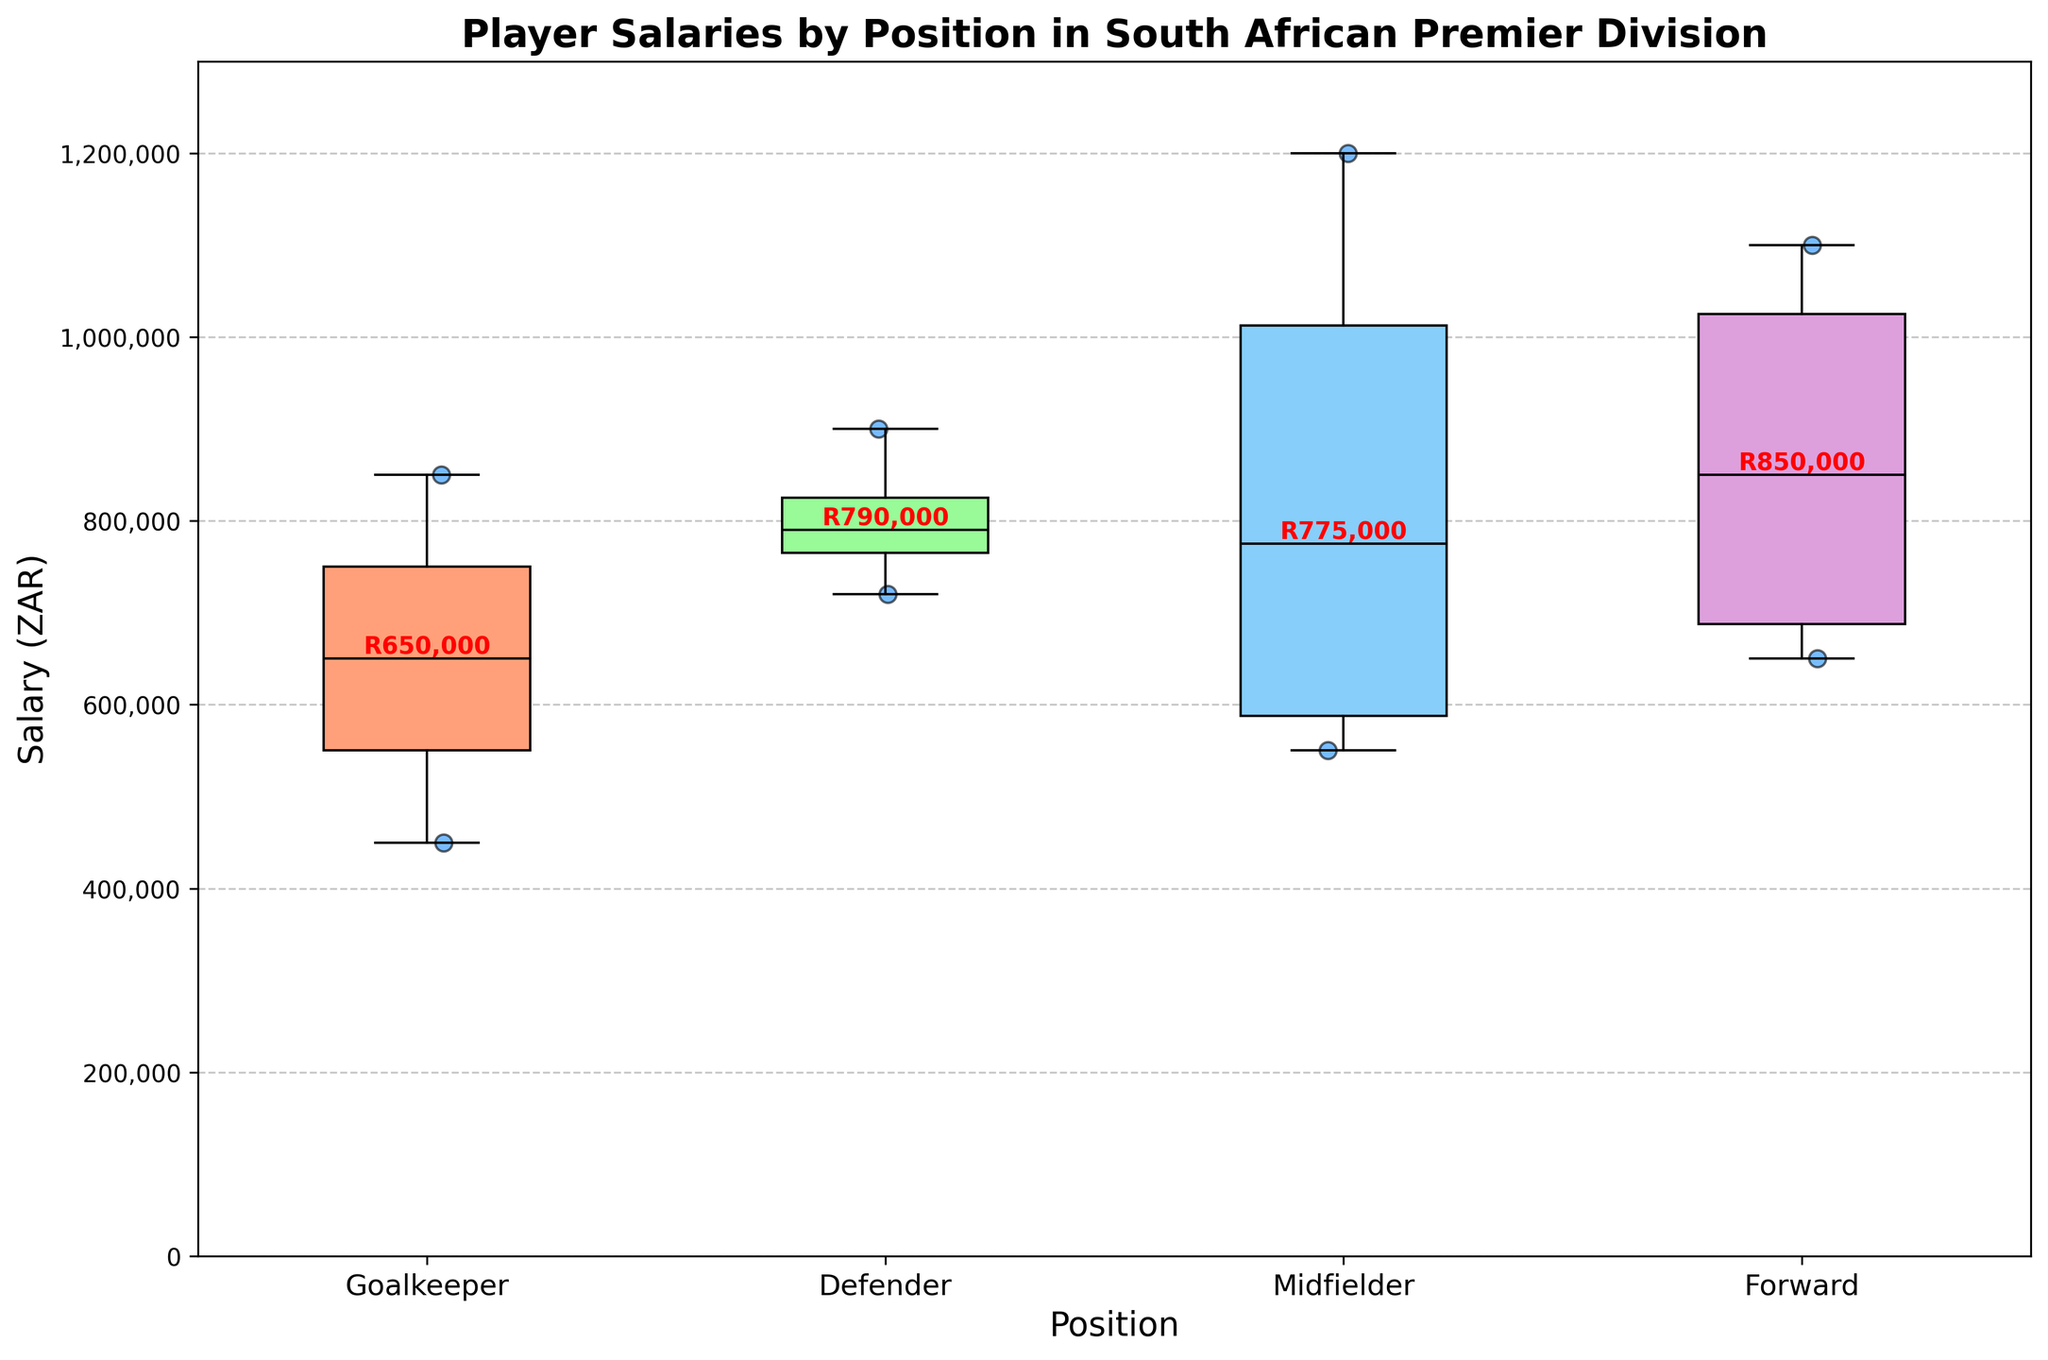What is the title of the plot? The title of the plot is displayed at the top and reads "Player Salaries by Position in South African Premier Division".
Answer: Player Salaries by Position in South African Premier Division Which player's salary is represented as the highest scatter point? The highest point in the scatter plot is for Keagan Dolly, who is a midfielder with a salary of 1,200,000 ZAR.
Answer: Keagan Dolly What is the median salary for defenders? The median salary for defenders is displayed as text above the box plot for defenders. It is 760,000 ZAR.
Answer: 760,000 ZAR Which position has the highest median salary? By comparing the medians indicated above the box plots, midfielders have the highest median salary, with a red annotation showing 900,000 ZAR.
Answer: Midfielders Which position has the widest range of salaries? The range of salaries is the difference between the highest and lowest points in the box plot. Midfielders have the widest range, from around 550,000 ZAR to 1,200,000 ZAR.
Answer: Midfielders What is the lowest salary among forwards? The lowest salary among forwards is represented by the bottom whisker of the forwards’ box plot, which is 650,000 ZAR.
Answer: 650,000 ZAR How many goalkeepers are there in the data? The scatter plot for goalkeepers shows three distinct points, representing three goalkeepers.
Answer: 3 Are there any outliers in the midfielder salary distribution? There are no points outside the whiskers of the box plot for midfielders, indicating there are no outliers.
Answer: No How does the median salary of goalkeepers compare to defenders? From the box plot, the median salary of goalkeepers is lower than that of defenders. The goalkeepers’ median is 650,000 ZAR while the defenders’ median is 760,000 ZAR.
Answer: Lower What is the approximate interquartile range (IQR) for forwards? The IQR is the range within the box itself, from the first quartile (Q1) to the third quartile (Q3). For forwards, it ranges from 650,000 ZAR to 1,000,000 ZAR. Therefore, IQR = 1,000,000 - 650,000 = 350,000 ZAR.
Answer: 350,000 ZAR 